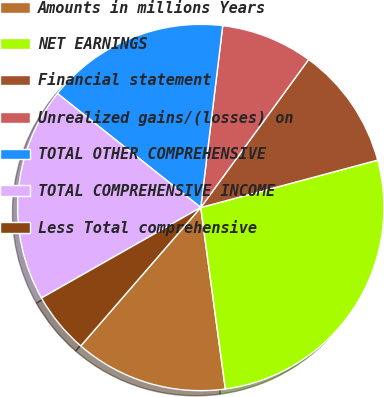Convert chart to OTSL. <chart><loc_0><loc_0><loc_500><loc_500><pie_chart><fcel>Amounts in millions Years<fcel>NET EARNINGS<fcel>Financial statement<fcel>Unrealized gains/(losses) on<fcel>TOTAL OTHER COMPREHENSIVE<fcel>TOTAL COMPREHENSIVE INCOME<fcel>Less Total comprehensive<nl><fcel>13.51%<fcel>27.02%<fcel>10.81%<fcel>8.11%<fcel>16.22%<fcel>18.92%<fcel>5.41%<nl></chart> 